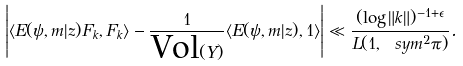<formula> <loc_0><loc_0><loc_500><loc_500>\left | \langle E ( \psi , m | z ) F _ { k } , F _ { k } \rangle - \frac { 1 } { \text {Vol} ( Y ) } \langle E ( \psi , m | z ) , 1 \rangle \right | \ll \frac { ( \log \| k \| ) ^ { - 1 + \epsilon } } { L ( 1 , \ s y m ^ { 2 } \pi ) } .</formula> 